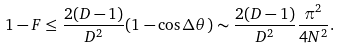<formula> <loc_0><loc_0><loc_500><loc_500>1 - F \leq \frac { 2 ( D - 1 ) } { D ^ { 2 } } ( 1 - \cos \Delta \theta ) \sim \frac { 2 ( D - 1 ) } { D ^ { 2 } } \frac { \pi ^ { 2 } } { 4 N ^ { 2 } } .</formula> 